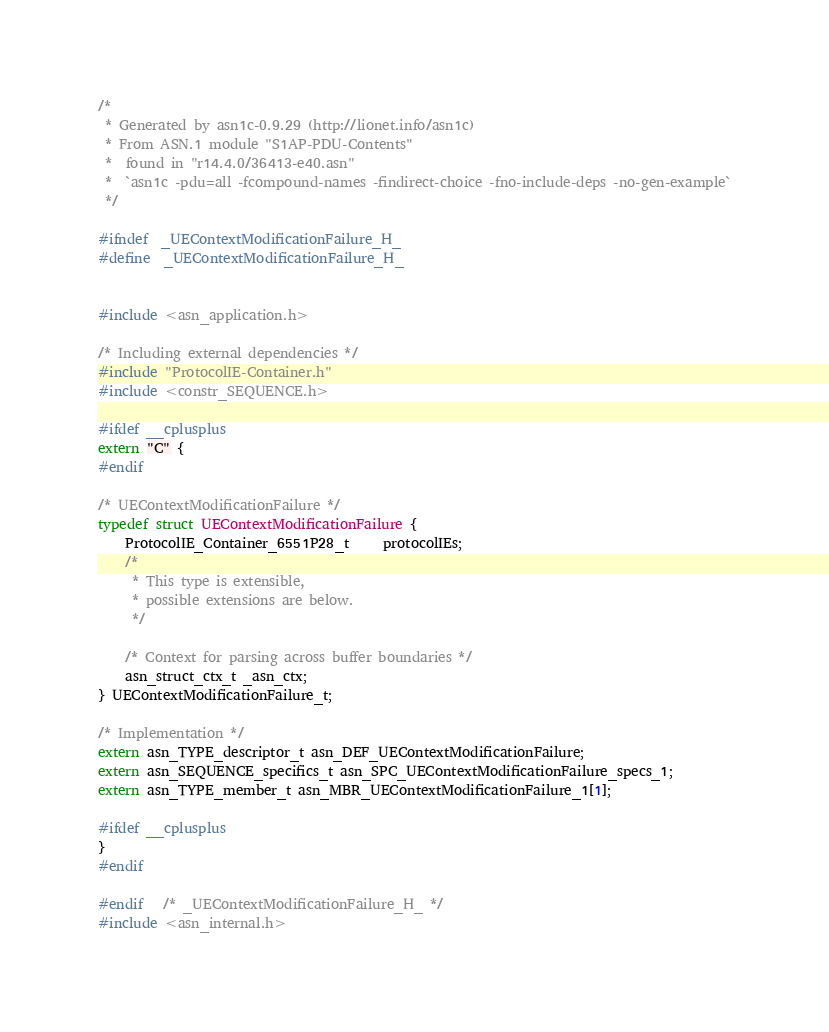Convert code to text. <code><loc_0><loc_0><loc_500><loc_500><_C_>/*
 * Generated by asn1c-0.9.29 (http://lionet.info/asn1c)
 * From ASN.1 module "S1AP-PDU-Contents"
 * 	found in "r14.4.0/36413-e40.asn"
 * 	`asn1c -pdu=all -fcompound-names -findirect-choice -fno-include-deps -no-gen-example`
 */

#ifndef	_UEContextModificationFailure_H_
#define	_UEContextModificationFailure_H_


#include <asn_application.h>

/* Including external dependencies */
#include "ProtocolIE-Container.h"
#include <constr_SEQUENCE.h>

#ifdef __cplusplus
extern "C" {
#endif

/* UEContextModificationFailure */
typedef struct UEContextModificationFailure {
	ProtocolIE_Container_6551P28_t	 protocolIEs;
	/*
	 * This type is extensible,
	 * possible extensions are below.
	 */
	
	/* Context for parsing across buffer boundaries */
	asn_struct_ctx_t _asn_ctx;
} UEContextModificationFailure_t;

/* Implementation */
extern asn_TYPE_descriptor_t asn_DEF_UEContextModificationFailure;
extern asn_SEQUENCE_specifics_t asn_SPC_UEContextModificationFailure_specs_1;
extern asn_TYPE_member_t asn_MBR_UEContextModificationFailure_1[1];

#ifdef __cplusplus
}
#endif

#endif	/* _UEContextModificationFailure_H_ */
#include <asn_internal.h>
</code> 